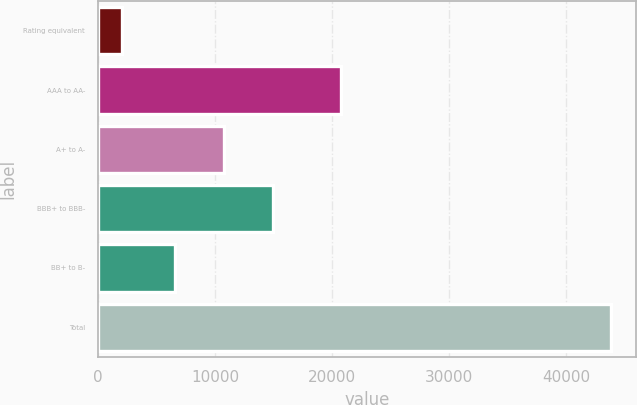Convert chart to OTSL. <chart><loc_0><loc_0><loc_500><loc_500><bar_chart><fcel>Rating equivalent<fcel>AAA to AA-<fcel>A+ to A-<fcel>BBB+ to BBB-<fcel>BB+ to B-<fcel>Total<nl><fcel>2005<fcel>20735<fcel>10758.2<fcel>14936.4<fcel>6580<fcel>43787<nl></chart> 